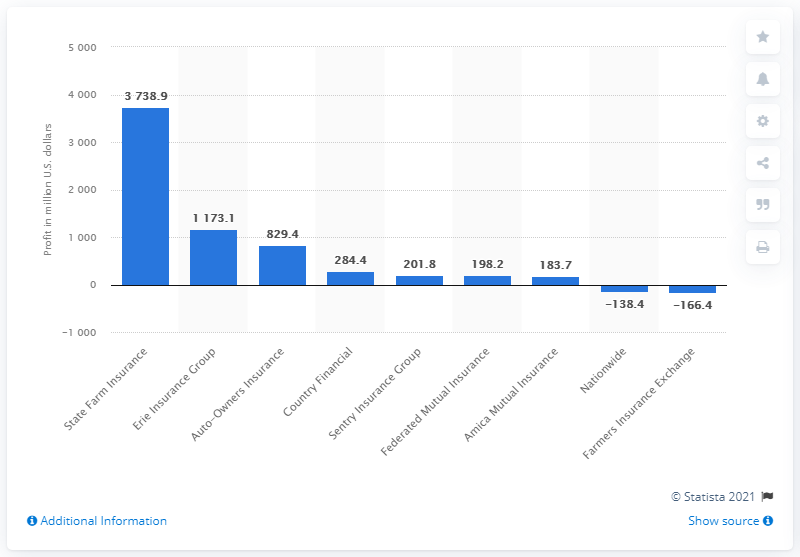Point out several critical features in this image. State Farm Insurance's profit in 2020 was $37,38.9 million. 